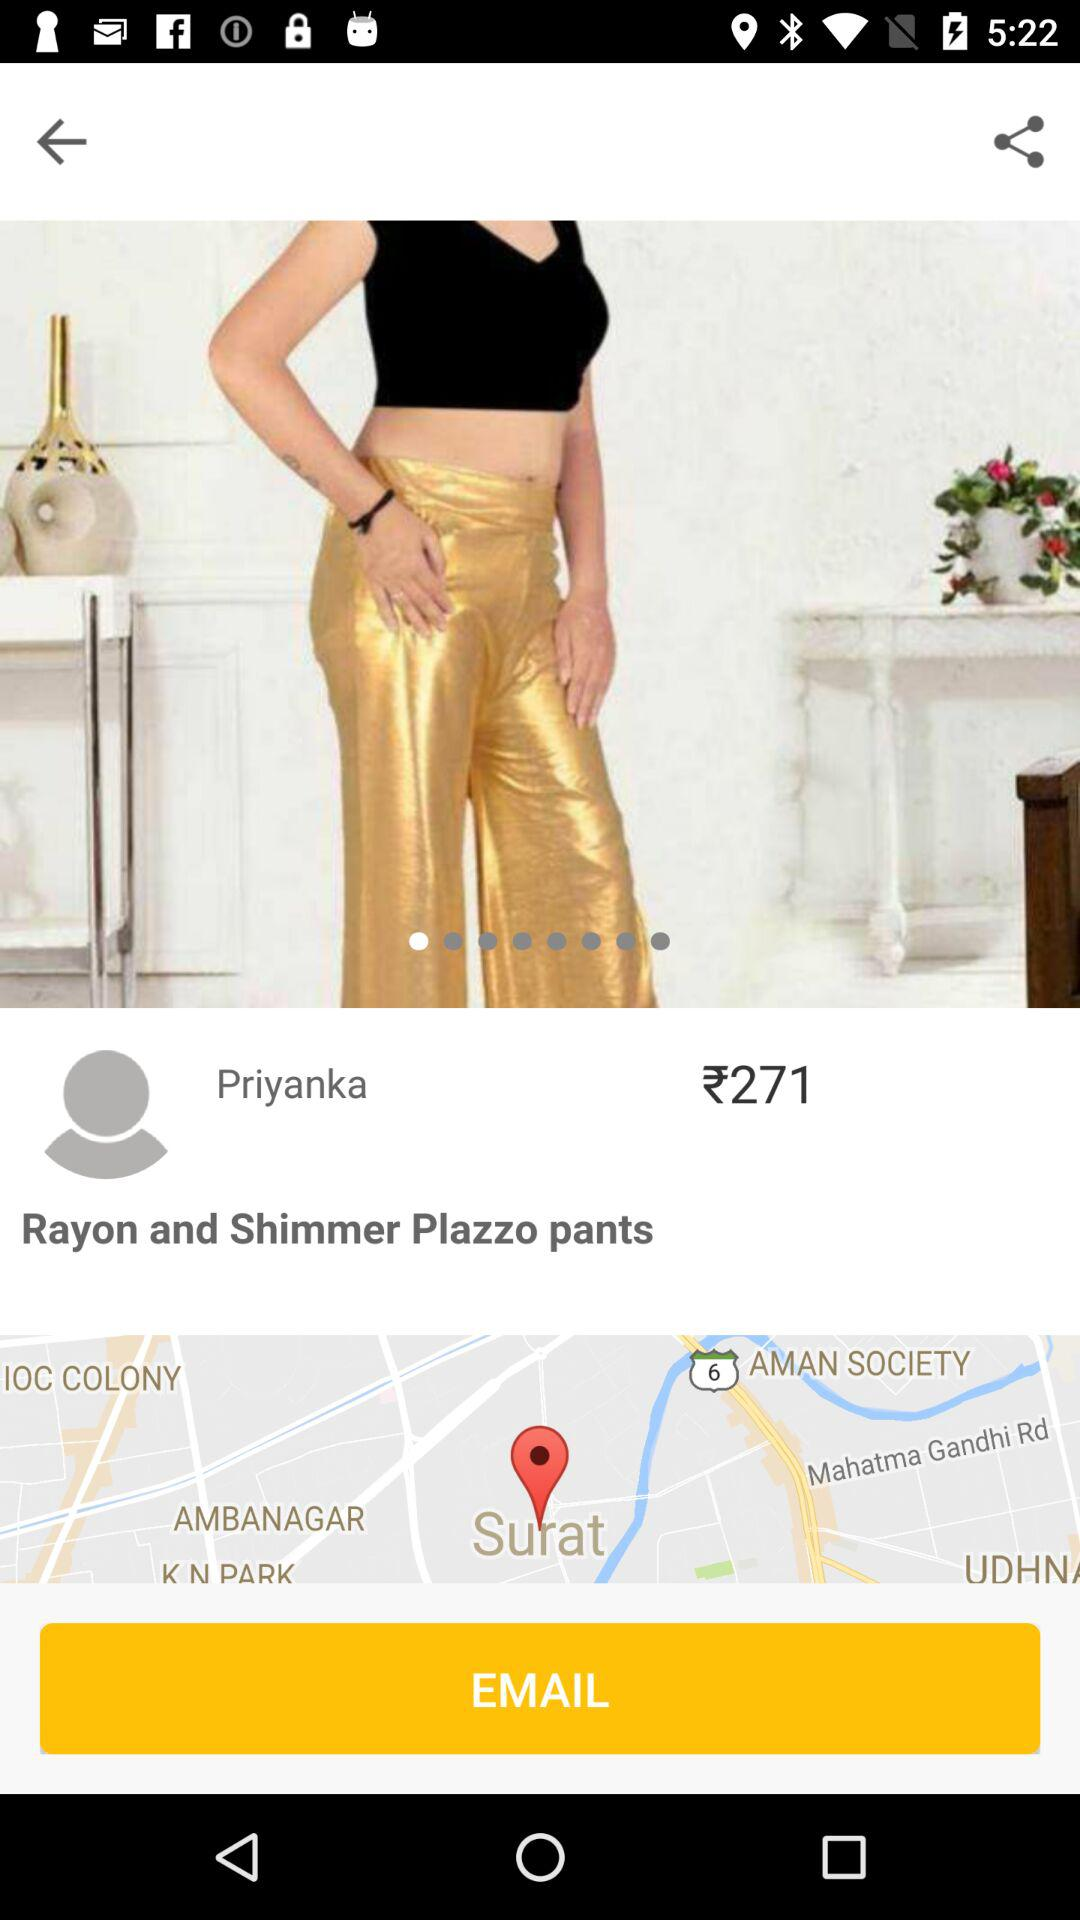What is the currency of the price? The currency is rupees. 